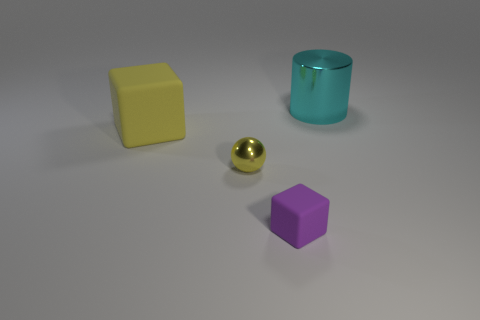Is there a small thing of the same color as the big matte thing?
Provide a succinct answer. Yes. Do the rubber object that is in front of the yellow rubber thing and the big object that is behind the large rubber cube have the same color?
Your response must be concise. No. The thing that is the same color as the shiny sphere is what size?
Provide a short and direct response. Large. Is there a small yellow thing made of the same material as the large block?
Offer a very short reply. No. What color is the tiny matte thing?
Provide a short and direct response. Purple. What is the size of the object that is behind the block that is behind the cube in front of the yellow block?
Your response must be concise. Large. What number of other things are the same shape as the small rubber object?
Provide a succinct answer. 1. There is a object that is behind the small metal object and on the left side of the big cyan metallic object; what is its color?
Provide a short and direct response. Yellow. Is there any other thing that is the same size as the cyan object?
Keep it short and to the point. Yes. Does the big thing right of the tiny shiny object have the same color as the big rubber object?
Offer a terse response. No. 